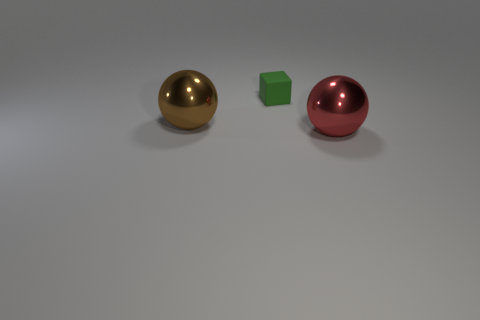Subtract all red spheres. How many spheres are left? 1 Add 2 tiny red objects. How many objects exist? 5 Subtract 1 cubes. How many cubes are left? 0 Subtract all cubes. How many objects are left? 2 Subtract all red shiny objects. Subtract all large brown things. How many objects are left? 1 Add 2 large brown metallic objects. How many large brown metallic objects are left? 3 Add 1 large brown metal blocks. How many large brown metal blocks exist? 1 Subtract 0 blue blocks. How many objects are left? 3 Subtract all blue cubes. Subtract all cyan spheres. How many cubes are left? 1 